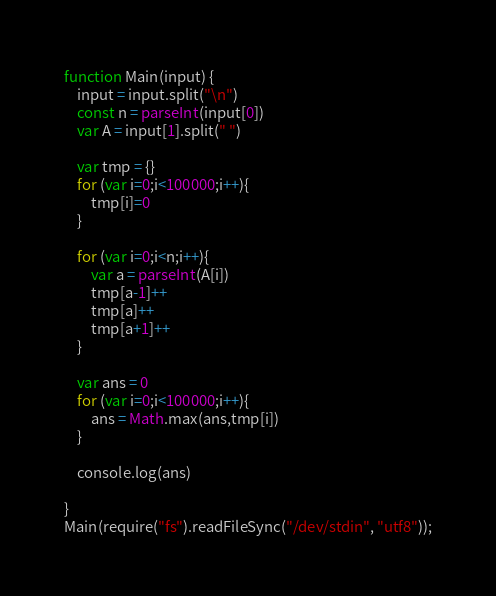<code> <loc_0><loc_0><loc_500><loc_500><_JavaScript_>function Main(input) {
    input = input.split("\n")
    const n = parseInt(input[0])
    var A = input[1].split(" ")
    
    var tmp = {}
    for (var i=0;i<100000;i++){
        tmp[i]=0
    }

    for (var i=0;i<n;i++){
        var a = parseInt(A[i])
        tmp[a-1]++
        tmp[a]++
        tmp[a+1]++
    }

    var ans = 0
    for (var i=0;i<100000;i++){
        ans = Math.max(ans,tmp[i])
    }
    
    console.log(ans)

}
Main(require("fs").readFileSync("/dev/stdin", "utf8"));
</code> 